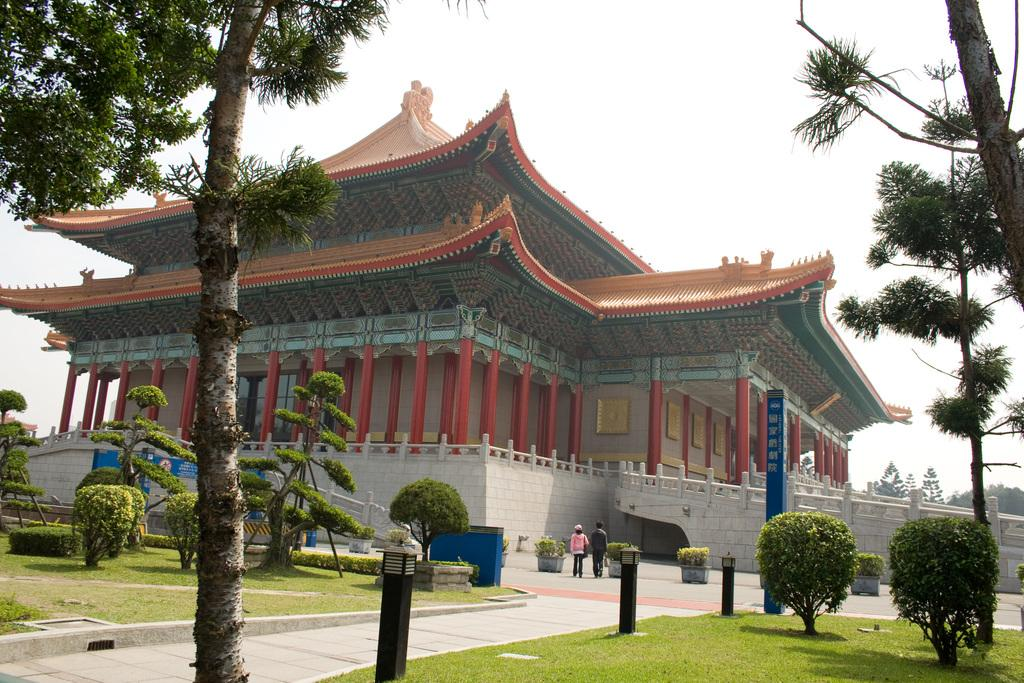What type of vegetation can be seen in the image? There is grass, trees, and plants visible in the image. What structures are present in the image? There are light poles, a board, and ancient architecture visible in the image. What are the people in the image doing? People are walking in the image. What can be seen in the background of the image? Trees and the sky are visible in the background of the image. What other objects are present in the image? There is a pole visible in the image. What type of light can be seen emanating from the governor in the image? There is no governor present in the image, and therefore no light can be emanating from it. What is the coefficient of friction between the people walking and the grass in the image? The provided facts do not include information about the friction between the people and the grass, so it cannot be determined. 